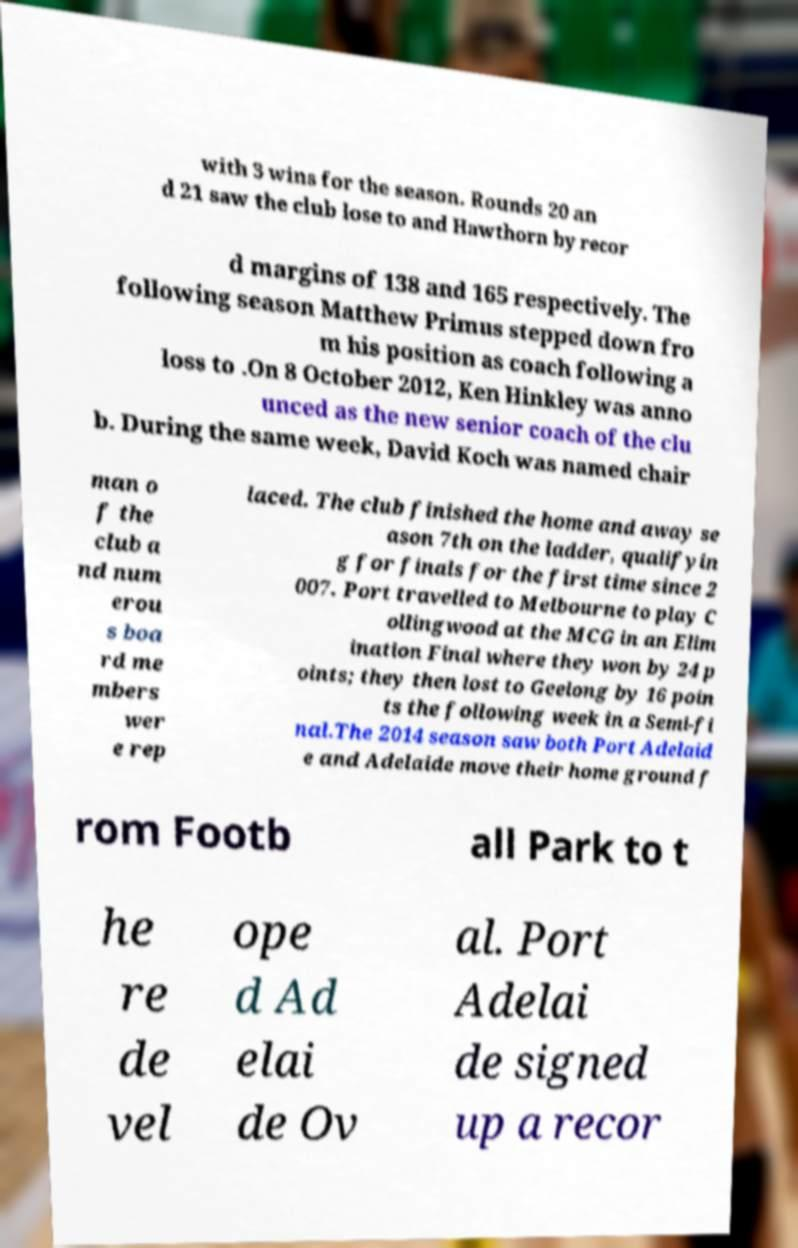There's text embedded in this image that I need extracted. Can you transcribe it verbatim? with 3 wins for the season. Rounds 20 an d 21 saw the club lose to and Hawthorn by recor d margins of 138 and 165 respectively. The following season Matthew Primus stepped down fro m his position as coach following a loss to .On 8 October 2012, Ken Hinkley was anno unced as the new senior coach of the clu b. During the same week, David Koch was named chair man o f the club a nd num erou s boa rd me mbers wer e rep laced. The club finished the home and away se ason 7th on the ladder, qualifyin g for finals for the first time since 2 007. Port travelled to Melbourne to play C ollingwood at the MCG in an Elim ination Final where they won by 24 p oints; they then lost to Geelong by 16 poin ts the following week in a Semi-fi nal.The 2014 season saw both Port Adelaid e and Adelaide move their home ground f rom Footb all Park to t he re de vel ope d Ad elai de Ov al. Port Adelai de signed up a recor 